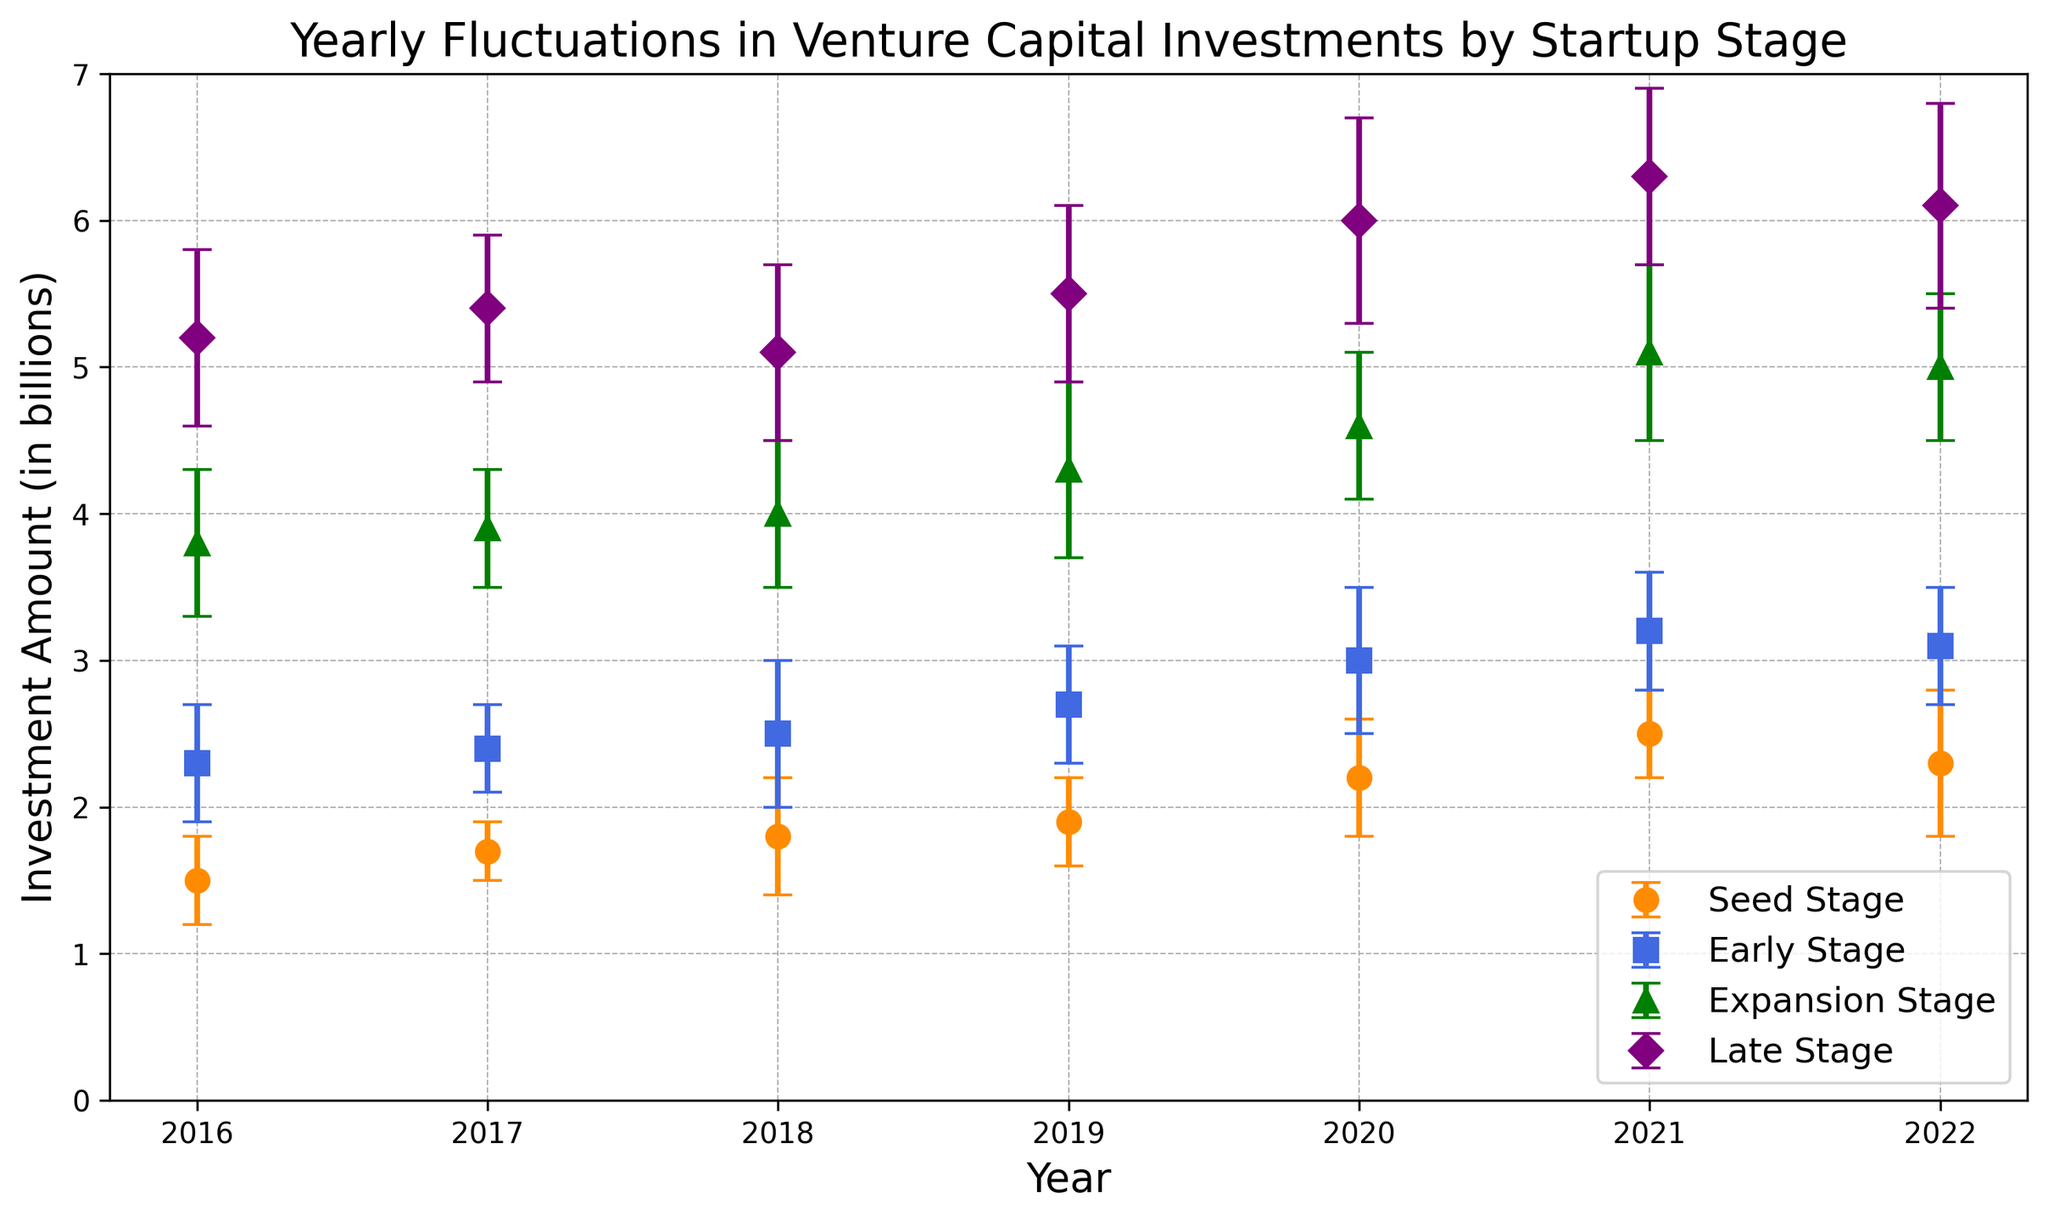What's the highest investment amount recorded in any late stage? Look at the data points for 'Late Stage' across all years. The maximum value is 6.3 billion, which occurs in 2021.
Answer: 6.3 billion Which stage shows the largest year-to-year fluctuation in investment amount? By examining the error bars, we see that the 'Late Stage' has larger error bars on average than other stages, indicating larger fluctuations.
Answer: Late Stage What is the average investment amount in the Seed Stage from 2016 to 2022? Sum the Seed Stage investments (1.5 + 1.7 + 1.8 + 1.9 + 2.2 + 2.5 + 2.3) and divide by the number of years (7). The sum is 13.9, and 13.9/7=1.99 (approx).
Answer: 1.99 billion Which year saw the highest investment amount in the Early Stage? Check the 'Early Stage' data points for each year. The highest value is 3.2 billion in 2021.
Answer: 2021 What is the difference between the highest and lowest average investment amounts in the Expansion Stage? The highest average investment is 5.1 billion (2021), and the lowest is 3.8 billion (2016). Thus, the difference is 5.1 - 3.8 = 1.3 billion.
Answer: 1.3 billion Which stage has the most consistent investment amount trend from 2016 to 2022? Consistency can be judged by the smaller error bars and steady growth. The 'Early Stage' shows smaller error bars and a steadily increasing trend compared to other stages.
Answer: Early Stage In which year did the Seed Stage investment cross the 2 billion mark for the first time? Checking the data points, Seed Stage investment first crosses 2 billion in 2020.
Answer: 2020 What stage has the highest variability in investment amounts? By comparing the size of the error bars, the 'Late Stage' shows the highest variability with larger error bars.
Answer: Late Stage If you combine the average investments in Early and Late stages for 2019, what would be the total? Early Stage average for 2019 is 2.7 billion and Late Stage is 5.5 billion. Summing them gives 2.7 + 5.5 = 8.2 billion.
Answer: 8.2 billion Which year saw the greatest increase in Seed Stage investments compared to the previous year? Comparing year-to-year increases: 2016 to 2017 (0.2), 2017 to 2018 (0.1), 2018 to 2019 (0.1), 2019 to 2020 (0.3), 2020 to 2021 (0.3). Both 2019 to 2020 and 2020 to 2021 show the greatest increase of 0.3 billion.
Answer: 2019 to 2020 and 2020 to 2021 